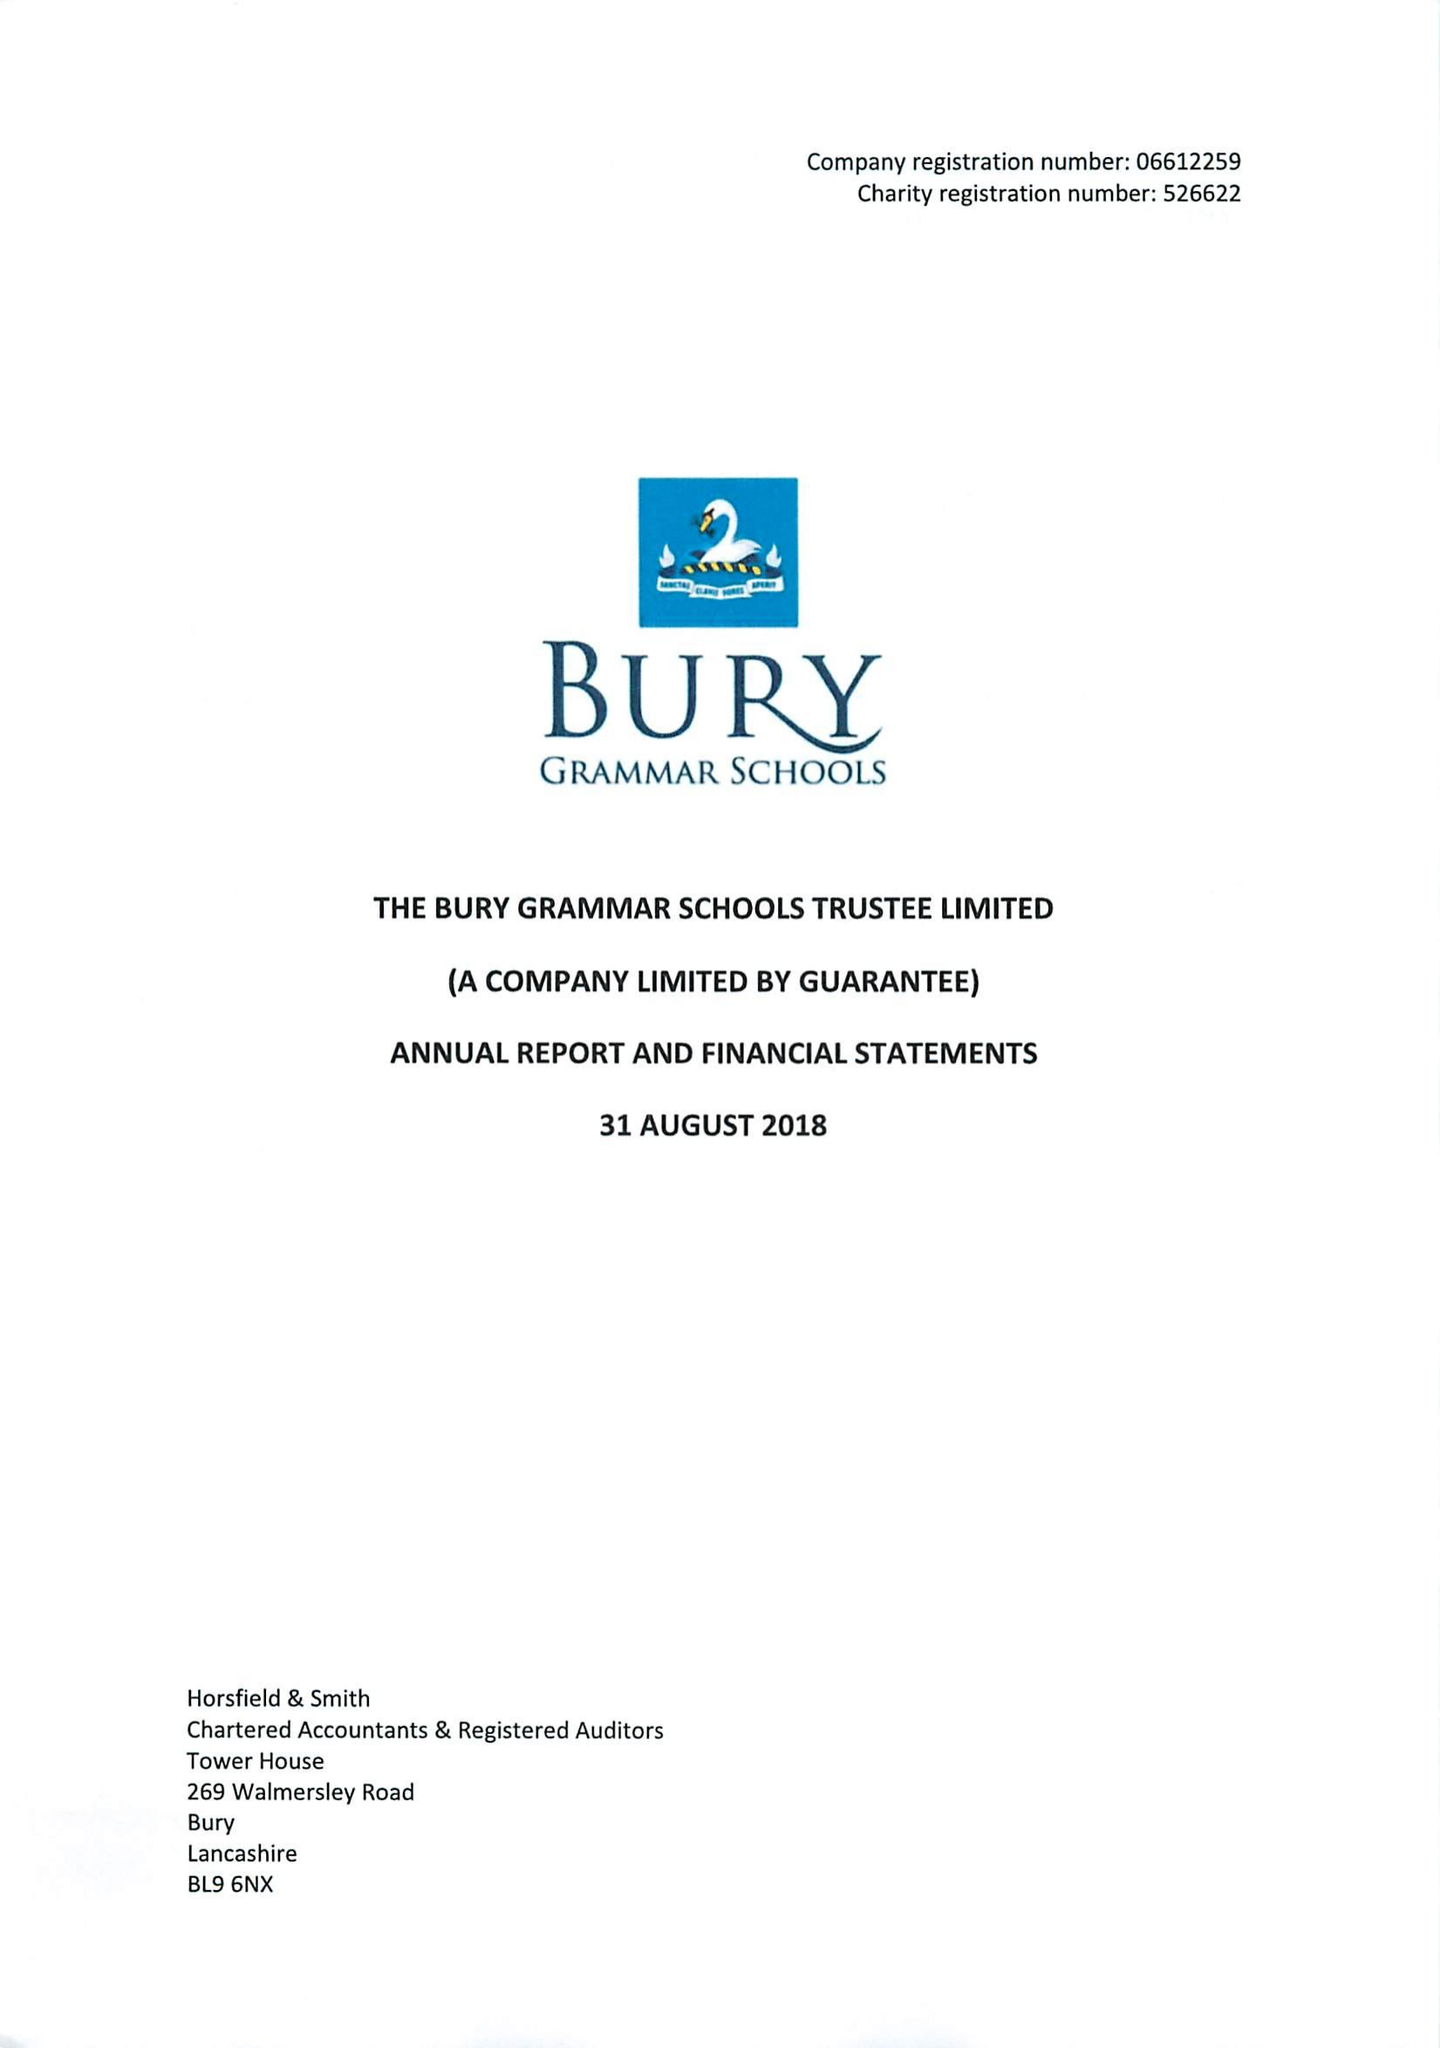What is the value for the income_annually_in_british_pounds?
Answer the question using a single word or phrase. 12376000.00 